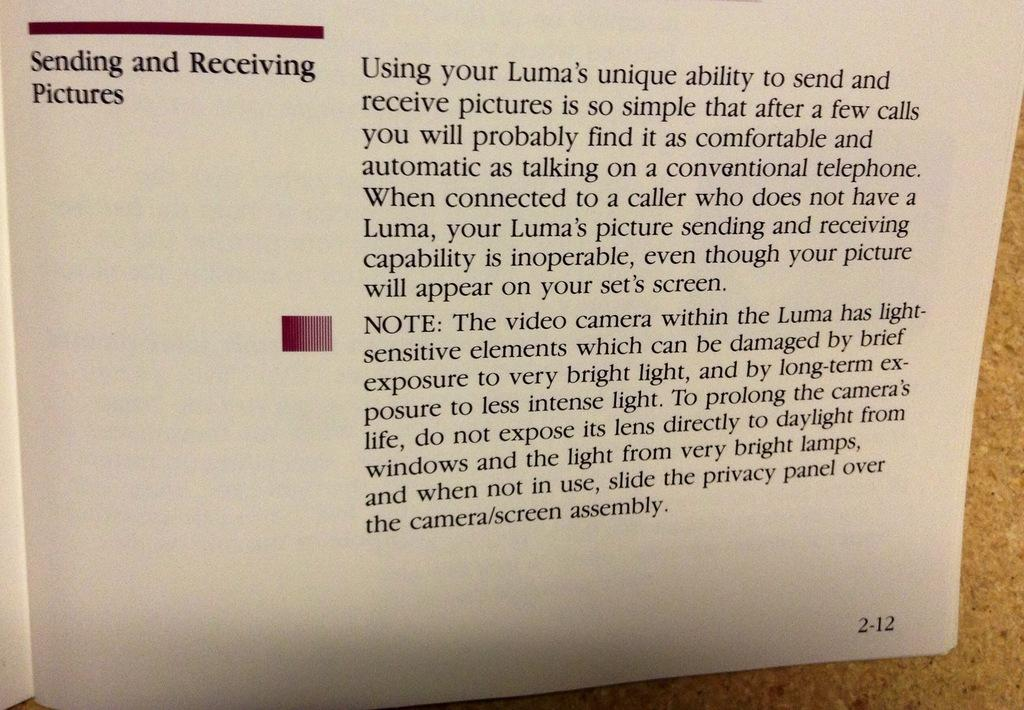Provide a one-sentence caption for the provided image. A user guide for sending and receiving pictures on a Luma is opened. 